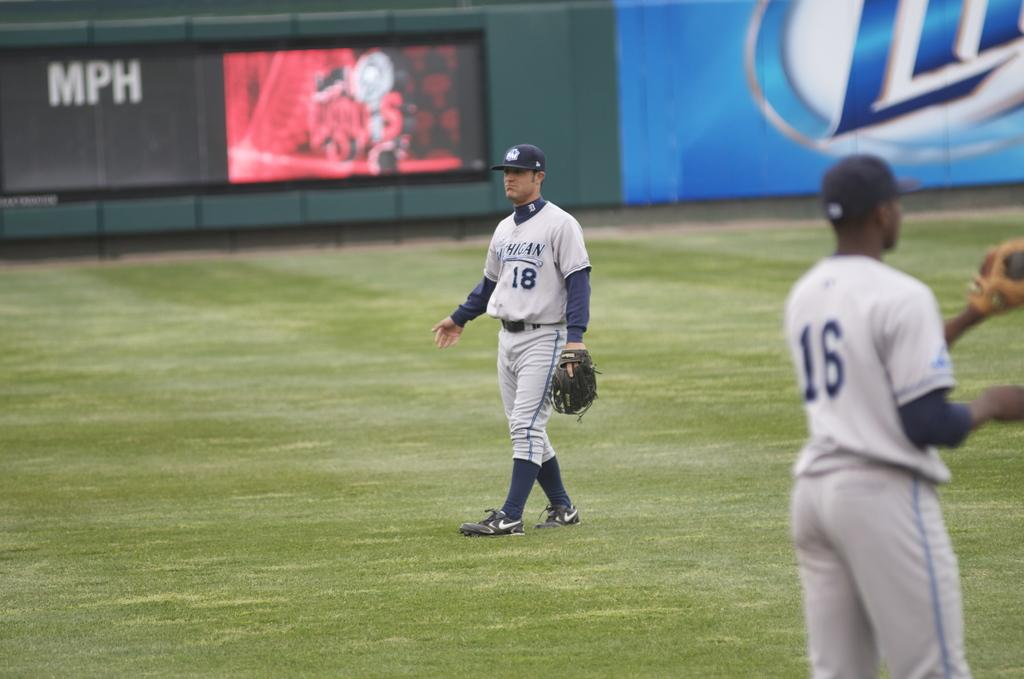Provide a one-sentence caption for the provided image. A baseball field with a lite beer ad in the background. 